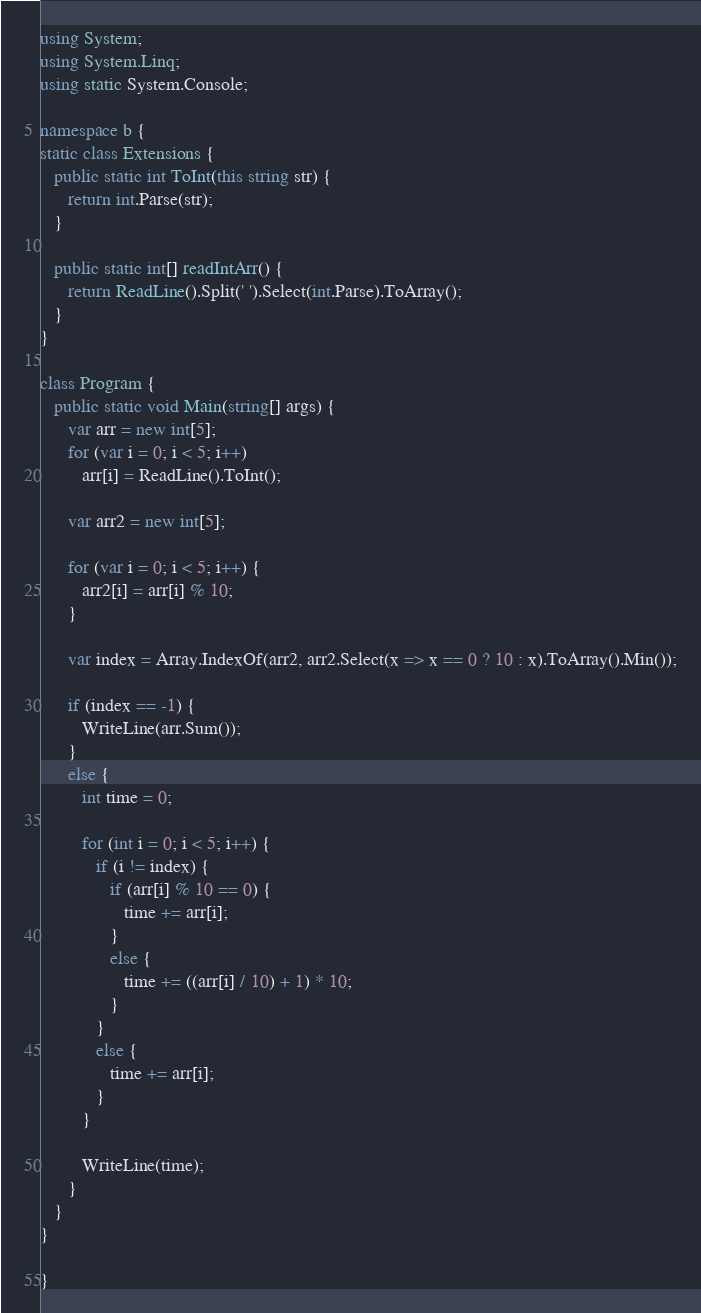Convert code to text. <code><loc_0><loc_0><loc_500><loc_500><_C#_>using System;
using System.Linq;
using static System.Console;

namespace b {
static class Extensions {
   public static int ToInt(this string str) {
      return int.Parse(str);
   }

   public static int[] readIntArr() {
      return ReadLine().Split(' ').Select(int.Parse).ToArray();
   }
}

class Program {
   public static void Main(string[] args) {
      var arr = new int[5];
      for (var i = 0; i < 5; i++)
         arr[i] = ReadLine().ToInt();

      var arr2 = new int[5];

      for (var i = 0; i < 5; i++) {
         arr2[i] = arr[i] % 10;
      }

      var index = Array.IndexOf(arr2, arr2.Select(x => x == 0 ? 10 : x).ToArray().Min());
      
      if (index == -1) {
         WriteLine(arr.Sum());
      }
      else {
         int time = 0;

         for (int i = 0; i < 5; i++) {
            if (i != index) {
               if (arr[i] % 10 == 0) {
                  time += arr[i];
               }
               else {
                  time += ((arr[i] / 10) + 1) * 10;
               }
            }
            else {
               time += arr[i];
            }
         }

         WriteLine(time);
      }
   }
}

}
</code> 